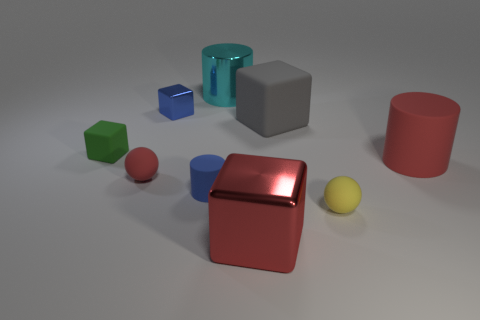Subtract all cyan cylinders. How many cylinders are left? 2 Add 1 big matte cubes. How many objects exist? 10 Subtract 1 spheres. How many spheres are left? 1 Subtract all cyan cylinders. How many cylinders are left? 2 Subtract all balls. How many objects are left? 7 Subtract all yellow cylinders. How many yellow blocks are left? 0 Add 2 yellow rubber spheres. How many yellow rubber spheres are left? 3 Add 1 tiny brown matte cylinders. How many tiny brown matte cylinders exist? 1 Subtract 1 blue cylinders. How many objects are left? 8 Subtract all red cubes. Subtract all yellow spheres. How many cubes are left? 3 